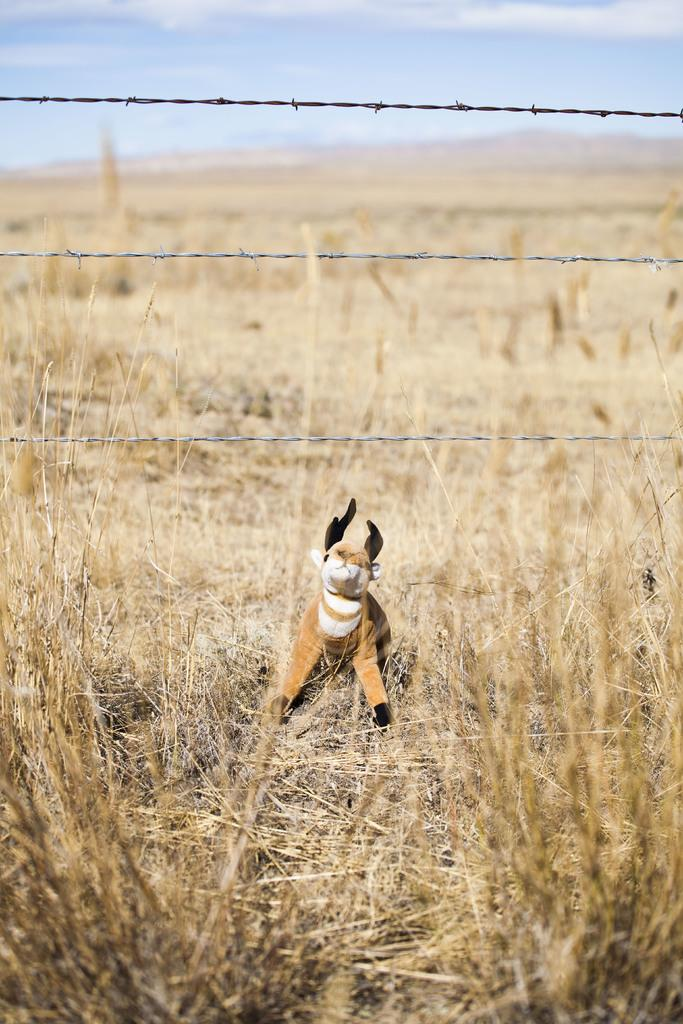What object in the image is typically associated with play or entertainment? There is a toy in the image. What type of natural vegetation is present in the image? There is dry grass in the image. What type of man-made structure is present in the image? There is fencing wire in the image. What is the color of the sky in the image? The sky is pale blue in the image. What type of noise can be heard coming from the potato in the image? There is no potato present in the image, and therefore no such noise can be heard. Where is the crib located in the image? There is no crib present in the image. 